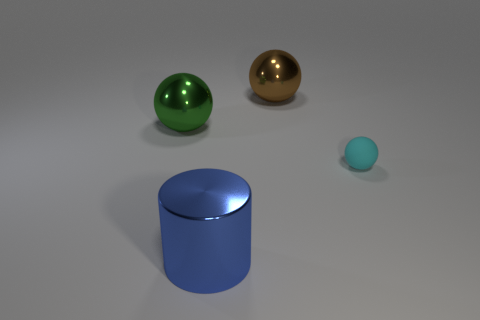Are there fewer big brown cylinders than spheres?
Give a very brief answer. Yes. How many big green spheres have the same material as the brown ball?
Provide a succinct answer. 1. The other large ball that is the same material as the brown ball is what color?
Offer a terse response. Green. What is the shape of the brown metal thing?
Offer a very short reply. Sphere. What number of objects are the same color as the shiny cylinder?
Give a very brief answer. 0. What shape is the blue metal thing that is the same size as the green metallic sphere?
Keep it short and to the point. Cylinder. Are there any other spheres of the same size as the cyan rubber sphere?
Your answer should be compact. No. There is a brown sphere that is the same size as the blue shiny object; what is it made of?
Offer a very short reply. Metal. What size is the object in front of the object that is on the right side of the brown shiny ball?
Offer a terse response. Large. There is a sphere that is to the right of the brown metallic object; is it the same size as the blue object?
Provide a succinct answer. No. 